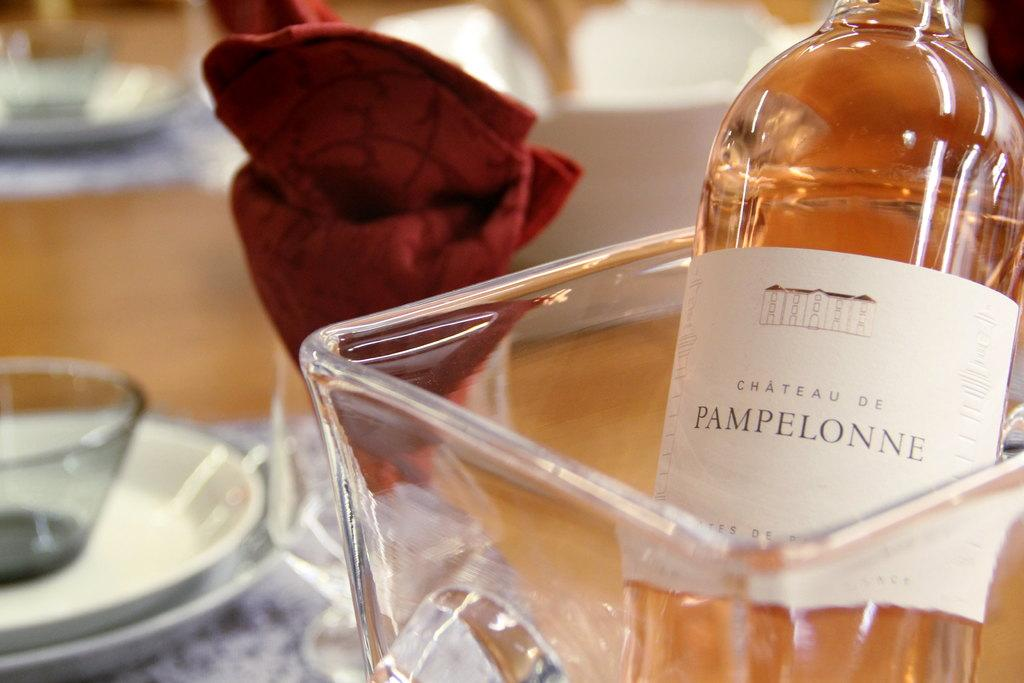<image>
Present a compact description of the photo's key features. the word Pampelonne that is on a bottle 